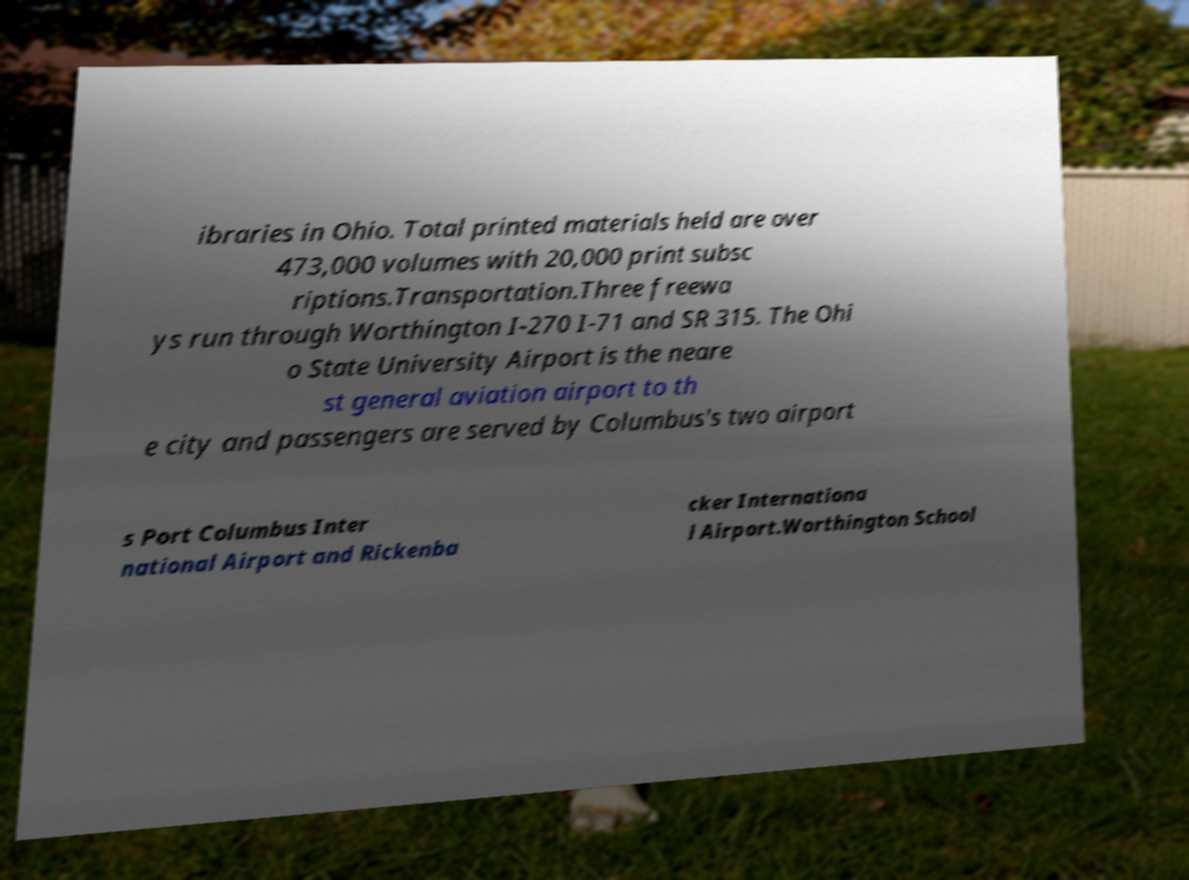Please read and relay the text visible in this image. What does it say? ibraries in Ohio. Total printed materials held are over 473,000 volumes with 20,000 print subsc riptions.Transportation.Three freewa ys run through Worthington I-270 I-71 and SR 315. The Ohi o State University Airport is the neare st general aviation airport to th e city and passengers are served by Columbus's two airport s Port Columbus Inter national Airport and Rickenba cker Internationa l Airport.Worthington School 